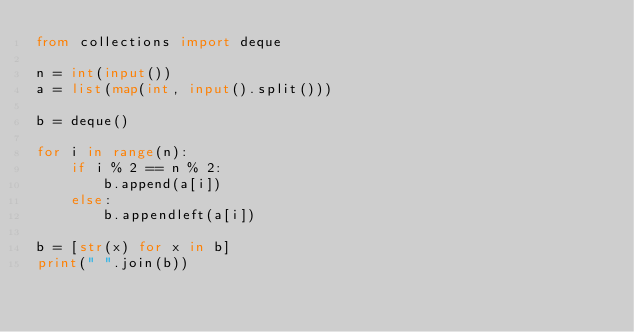Convert code to text. <code><loc_0><loc_0><loc_500><loc_500><_Python_>from collections import deque

n = int(input())
a = list(map(int, input().split()))

b = deque()

for i in range(n):
    if i % 2 == n % 2:
        b.append(a[i])
    else:
        b.appendleft(a[i])

b = [str(x) for x in b]
print(" ".join(b))
</code> 